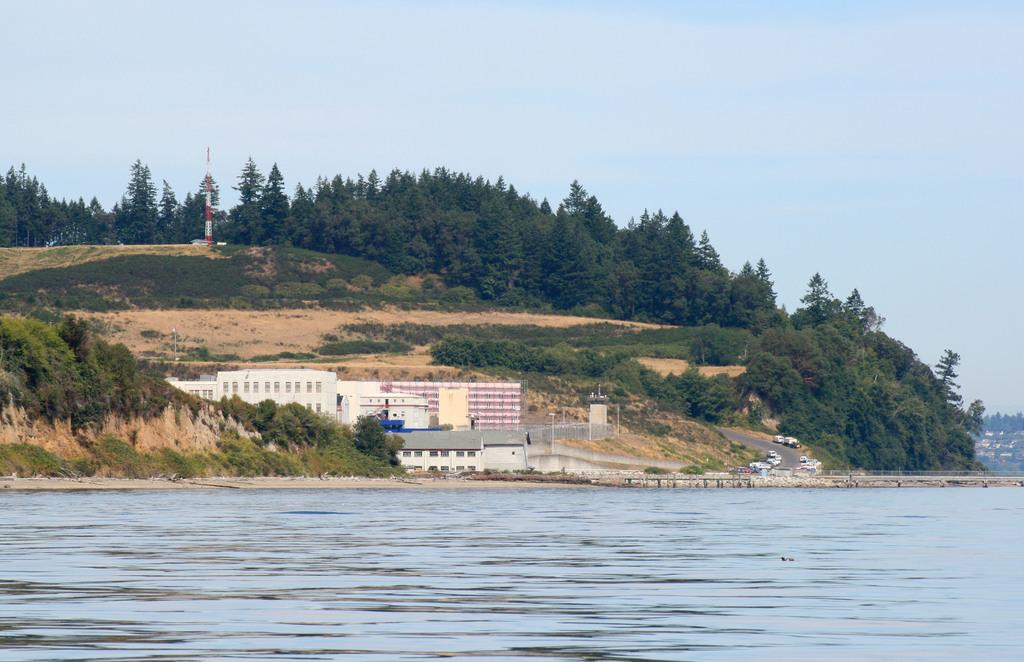What type of natural feature is at the bottom of the image? There is a river at the bottom of the image. What can be seen in the center of the image? Buildings, trees, plants, a walkway, vehicles, and poles are visible in the center of the image. What is the sky like in the image? The sky is visible at the top of the image. How many boys are smiling in the image? There are no boys or smiles present in the image. What grade is the river in the image? The river is not a student and therefore does not have a grade. 